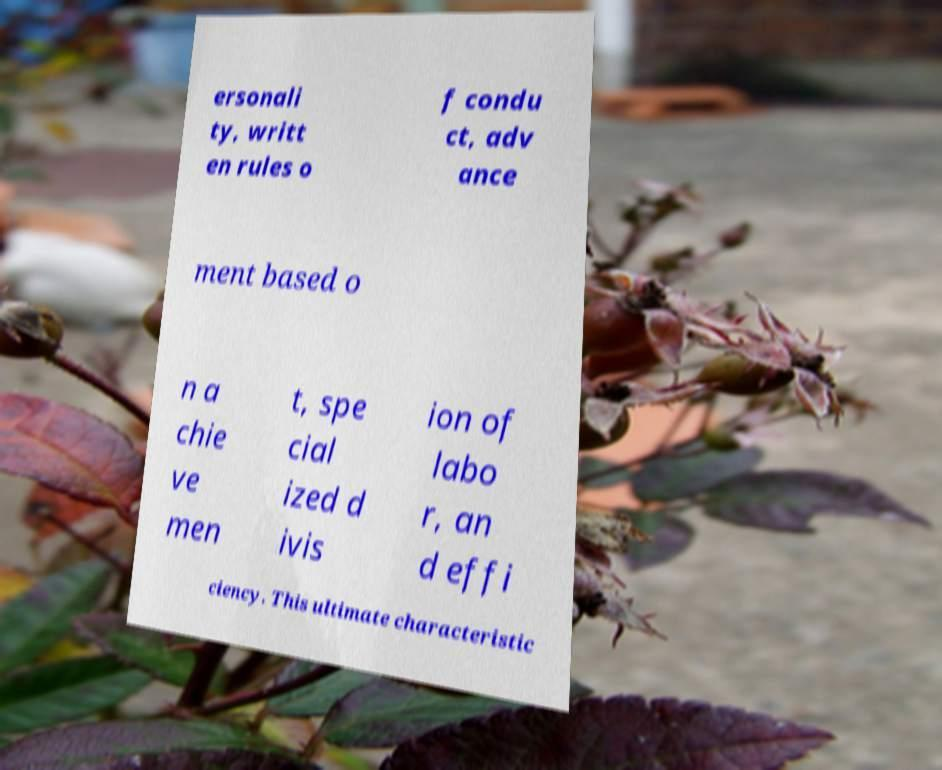I need the written content from this picture converted into text. Can you do that? ersonali ty, writt en rules o f condu ct, adv ance ment based o n a chie ve men t, spe cial ized d ivis ion of labo r, an d effi ciency. This ultimate characteristic 